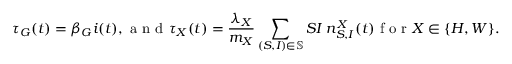Convert formula to latex. <formula><loc_0><loc_0><loc_500><loc_500>\tau _ { G } ( t ) = \beta _ { G } i ( t ) , a n d \tau _ { X } ( t ) = \frac { \lambda _ { X } } { m _ { X } } \sum _ { ( S , I ) \in \mathbb { S } } S I \, n _ { S , I } ^ { X } ( t ) f o r X \in \{ H , W \} .</formula> 